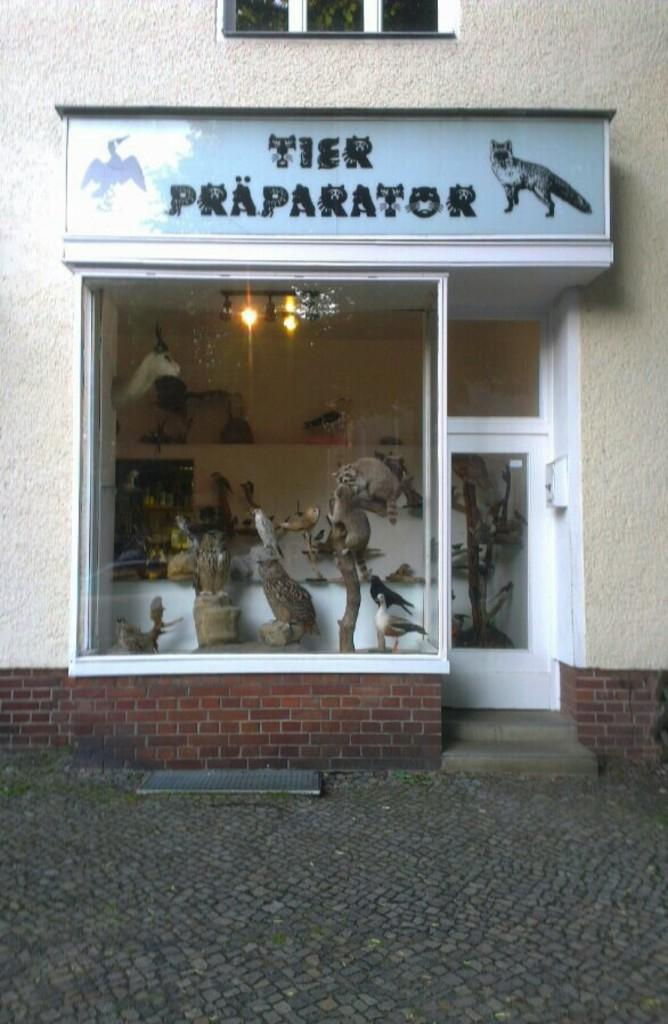What type of surface is visible in the image? There is a floor in the image. What can be seen on the floor in the image? There is a name board in the image. What architectural feature is present in the image? There is a window in the image. What is another feature that allows access to the space in the image? There is a door in the image. What surrounds the space in the image? There are walls in the image. What provides illumination in the image? There are lights in the image. What type of living creatures are present in the image? There are birds and animals in the image. What objects are made of wood and can be seen in the image? There are wooden sticks in the image. What other objects can be seen in the image? There are some objects in the image. What color is the orange in the image? There is no orange present in the image. What is the relationship between the person in the image and their brother? There is no person or brother mentioned in the image. What type of smell can be detected in the image? The image does not provide any information about smells. 